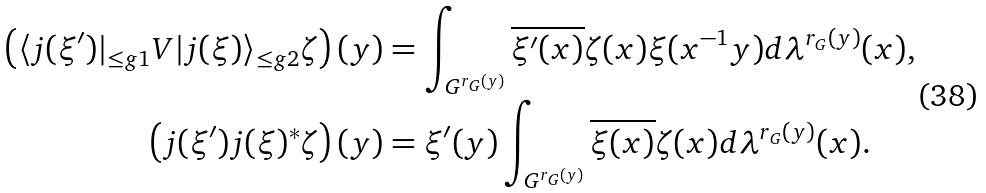<formula> <loc_0><loc_0><loc_500><loc_500>\left ( \langle j ( \xi ^ { \prime } ) | _ { \leq g { 1 } } V | j ( \xi ) \rangle _ { \leq g { 2 } } \zeta \right ) ( y ) & = \int _ { G ^ { r _ { G } ( y ) } } \overline { \xi ^ { \prime } ( x ) } \zeta ( x ) \xi ( x ^ { - 1 } y ) d \lambda ^ { r _ { G } ( y ) } ( x ) , \\ \left ( j ( \xi ^ { \prime } ) j ( \xi ) ^ { * } \zeta \right ) ( y ) & = \xi ^ { \prime } ( y ) \int _ { G ^ { r _ { G } ( y ) } } \overline { \xi ( x ) } \zeta ( x ) d \lambda ^ { r _ { G } ( y ) } ( x ) .</formula> 